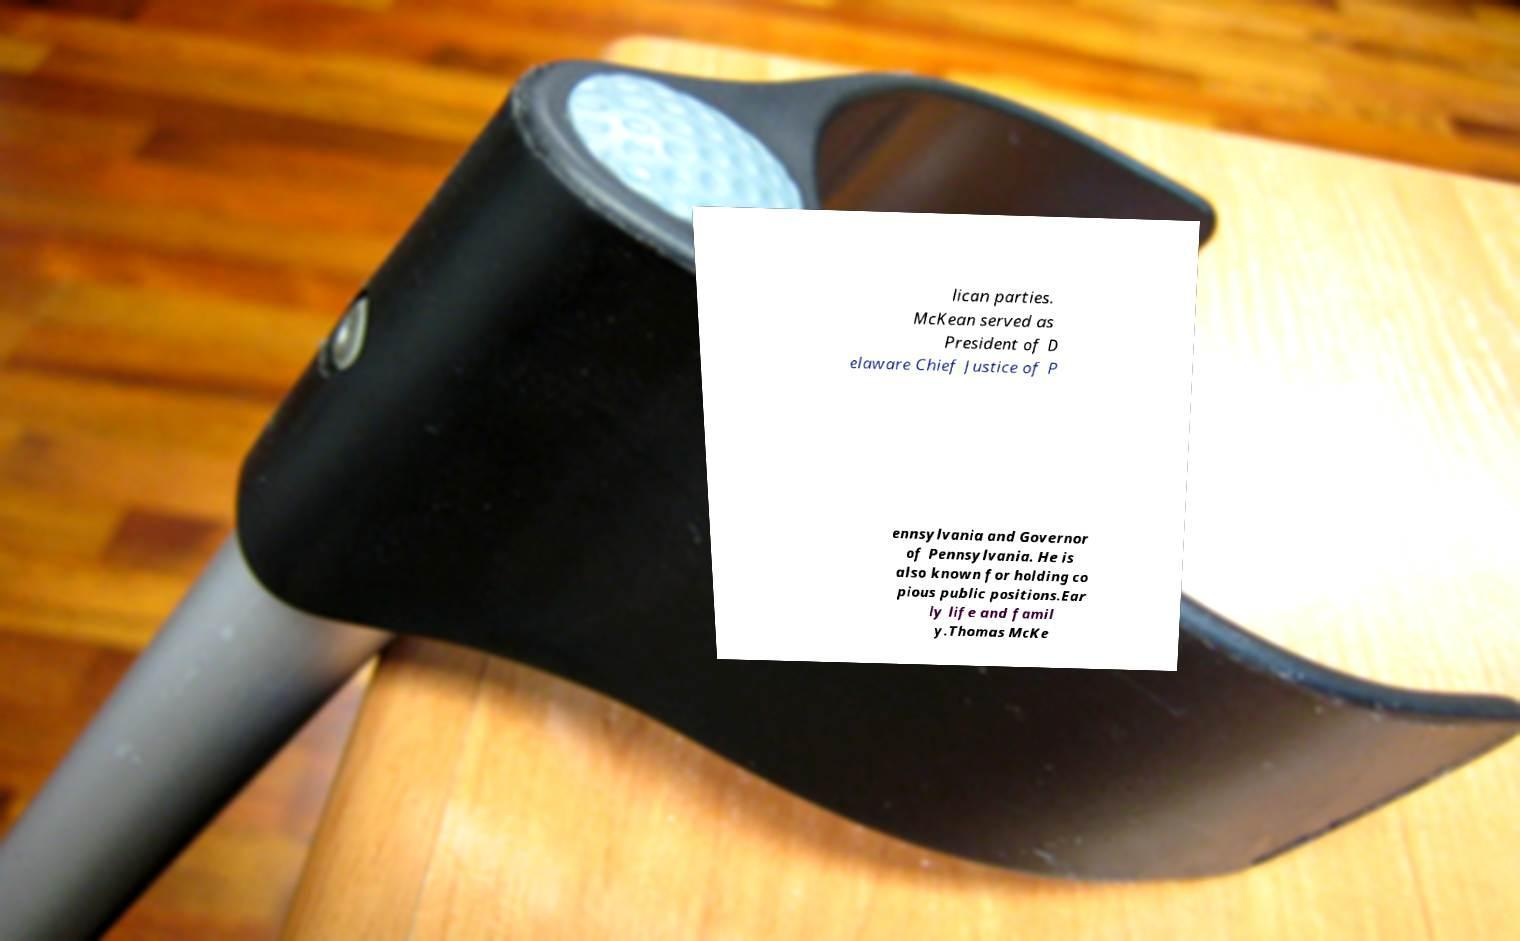Can you read and provide the text displayed in the image?This photo seems to have some interesting text. Can you extract and type it out for me? lican parties. McKean served as President of D elaware Chief Justice of P ennsylvania and Governor of Pennsylvania. He is also known for holding co pious public positions.Ear ly life and famil y.Thomas McKe 